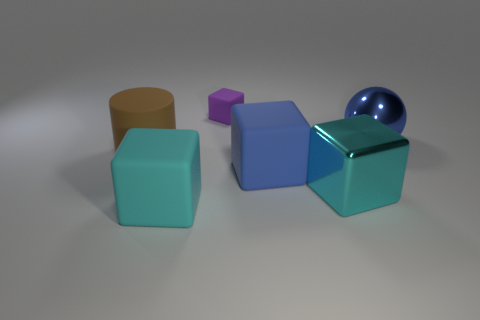How many metal things are either big purple cylinders or big balls?
Make the answer very short. 1. The metallic object that is the same shape as the cyan matte thing is what color?
Make the answer very short. Cyan. Are there any purple matte cubes?
Provide a short and direct response. Yes. Is the ball to the right of the small thing made of the same material as the large cyan object left of the purple matte block?
Offer a very short reply. No. There is a large thing that is the same color as the ball; what shape is it?
Offer a terse response. Cube. How many objects are either big blue things in front of the shiny ball or big rubber blocks that are in front of the big blue matte thing?
Provide a succinct answer. 2. There is a rubber cube behind the blue shiny ball; is its color the same as the shiny object that is behind the matte cylinder?
Your answer should be compact. No. There is a object that is behind the brown rubber cylinder and on the left side of the large blue sphere; what is its shape?
Your answer should be compact. Cube. What color is the metallic block that is the same size as the blue sphere?
Your response must be concise. Cyan. Is there another matte cylinder that has the same color as the matte cylinder?
Offer a terse response. No. 